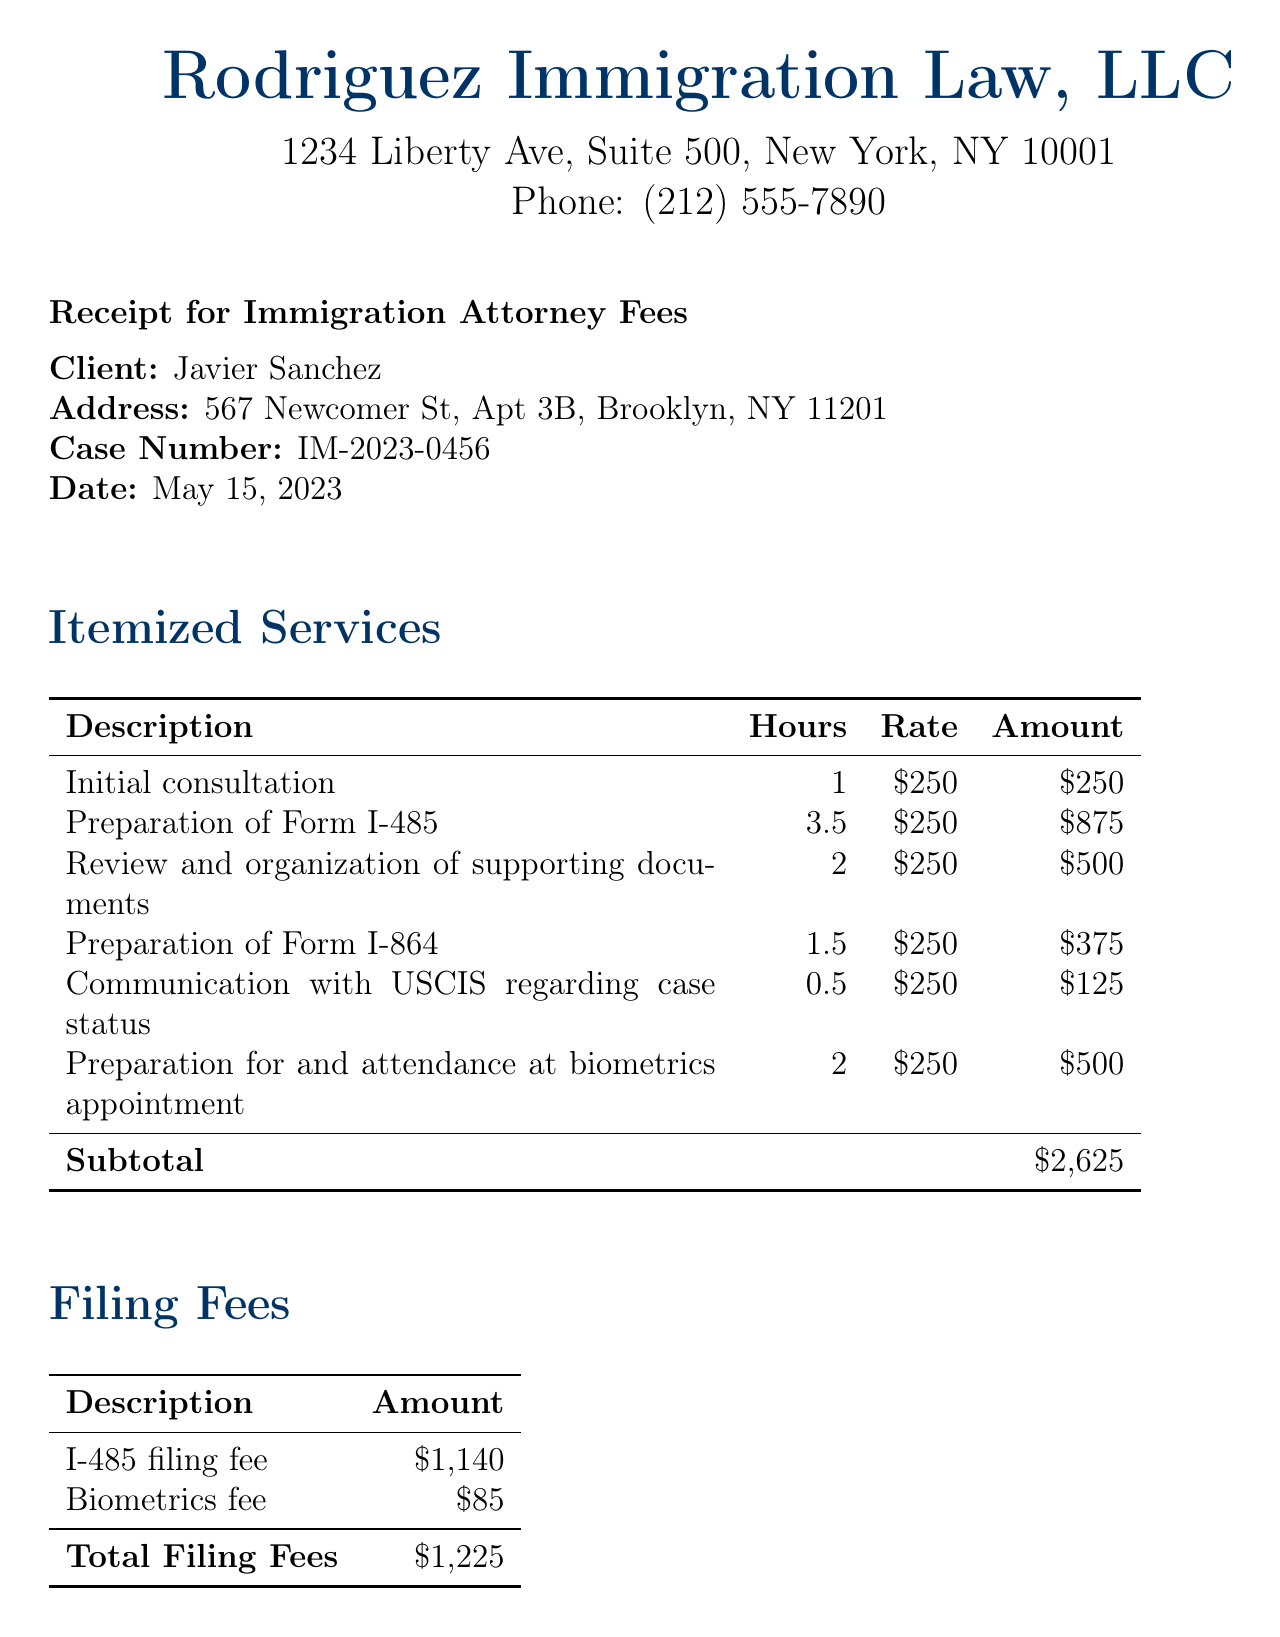What is the total due amount? The total due amount is listed at the bottom of the receipt, which combines subtotal for services and total filing fees.
Answer: $3,850 Who is the attorney? The attorney’s name is listed in the document as the person responsible for the services provided.
Answer: Maria Rodriguez What is the date of the receipt? The receipt includes the date at the top section.
Answer: May 15, 2023 How much was charged for the preparation of Form I-485? This information can be found in the itemized services section detailing the specific charge.
Answer: $875 What is the filing fee for the I-485 form? The document specifically breaks down the filing fees, including the I-485 fee.
Answer: $1,140 How many hours were spent on the initial consultation? The itemized services section specifies the number of hours for each service description.
Answer: 1 What payment methods are accepted? The document lists the accepted payment methods towards the end.
Answer: Check, Credit Card, Wire Transfer What services are listed under itemized services? The itemized services section enumerates the services provided, which are detailed in the table.
Answer: Initial consultation, Preparation of Form I-485, Review and organization of supporting documents, Preparation of Form I-864, Communication with USCIS regarding case status, Preparation for and attendance at biometrics appointment What is stated in the notes section? The notes section includes brief comments related to the payment and appreciation towards the client.
Answer: Payment is due upon receipt. Thank you for choosing Rodriguez Immigration Law, LLC for your immigration needs. We appreciate your commitment to following the legal immigration process 